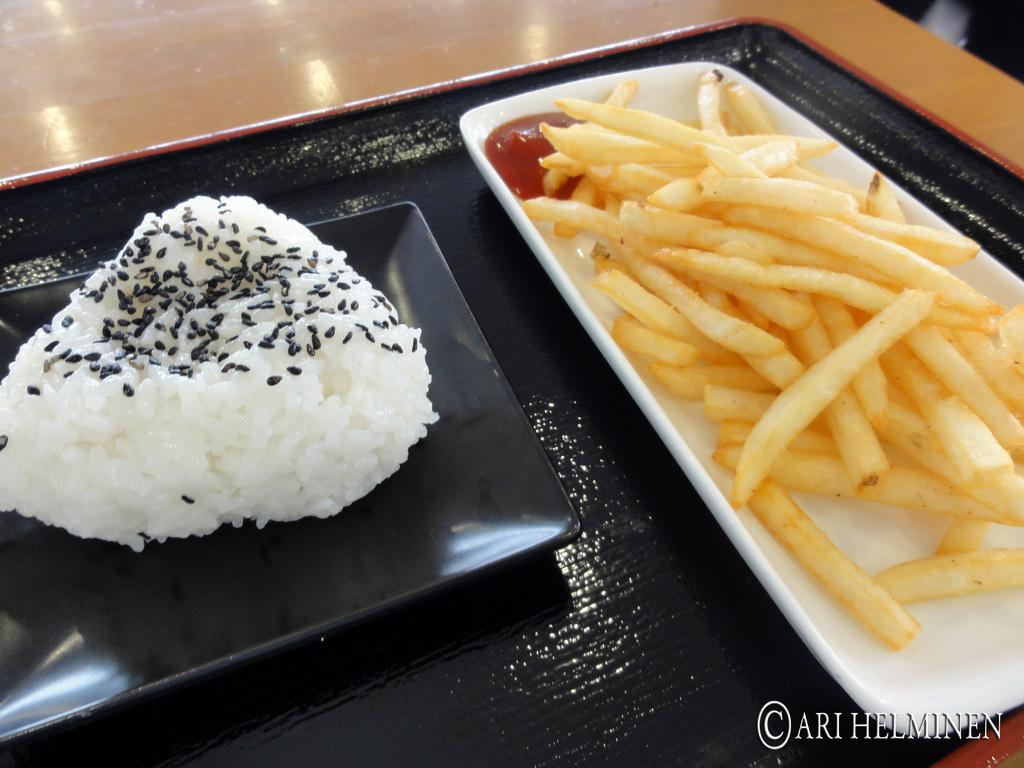What is placed on the table in the image? There is a tray on a table in the image. What can be found on the tray? There are two plates with food items on the tray. How many pigs are sitting on the furniture in the image? There are no pigs or furniture present in the image. 